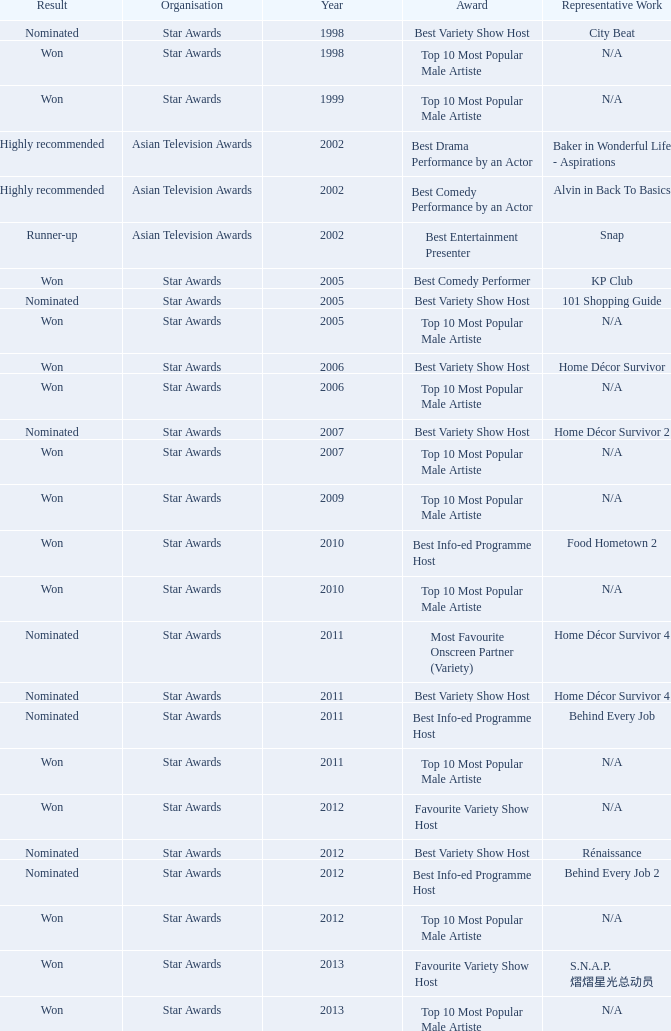What is the name of the Representative Work in a year later than 2005 with a Result of nominated, and an Award of best variety show host? Home Décor Survivor 2, Home Décor Survivor 4, Rénaissance, Jobs Around The World. 